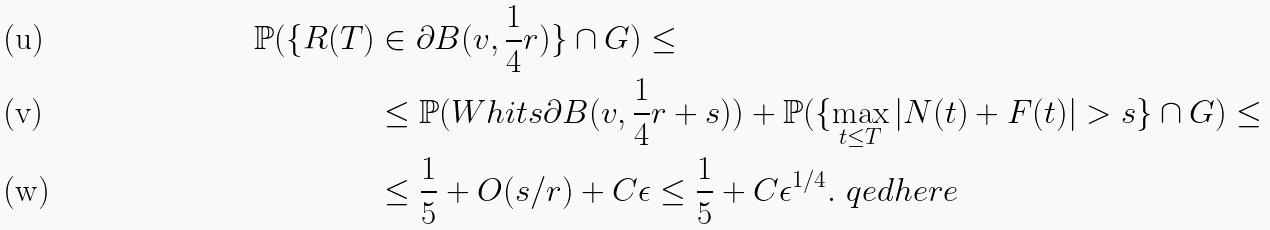<formula> <loc_0><loc_0><loc_500><loc_500>\mathbb { P } ( \{ R ( T ) & \in \partial B ( v , { \frac { 1 } { 4 } } r ) \} \cap G ) \leq \\ & \leq \mathbb { P } ( W h i t s \partial B ( v , { \frac { 1 } { 4 } } r + s ) ) + \mathbb { P } ( \{ \max _ { t \leq T } | N ( t ) + F ( t ) | > s \} \cap G ) \leq \\ & \leq \frac { 1 } { 5 } + O ( s / r ) + C \epsilon \leq \frac { 1 } { 5 } + C \epsilon ^ { 1 / 4 } . \ q e d h e r e</formula> 